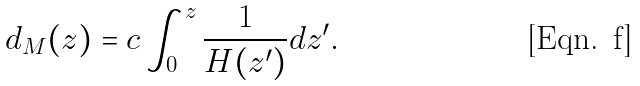Convert formula to latex. <formula><loc_0><loc_0><loc_500><loc_500>d _ { M } ( z ) = c \int _ { 0 } ^ { z } \frac { 1 } { H ( z ^ { \prime } ) } d z ^ { \prime } .</formula> 